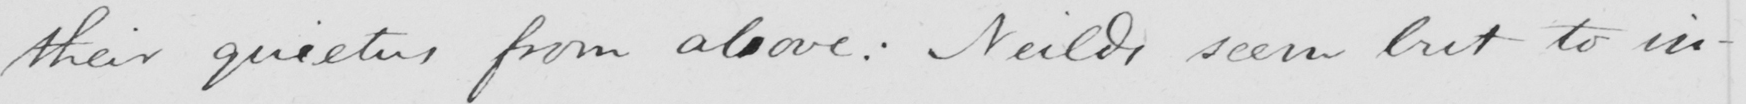Please provide the text content of this handwritten line. their quietus from above :  Neilds seem but to in- 